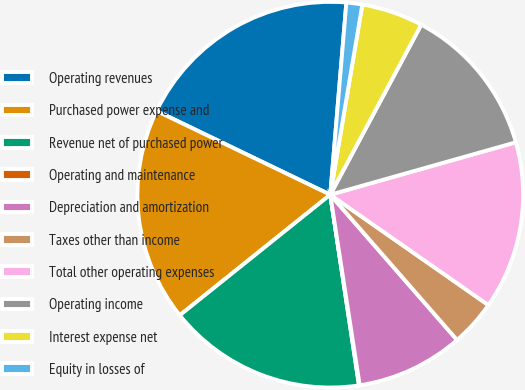Convert chart to OTSL. <chart><loc_0><loc_0><loc_500><loc_500><pie_chart><fcel>Operating revenues<fcel>Purchased power expense and<fcel>Revenue net of purchased power<fcel>Operating and maintenance<fcel>Depreciation and amortization<fcel>Taxes other than income<fcel>Total other operating expenses<fcel>Operating income<fcel>Interest expense net<fcel>Equity in losses of<nl><fcel>19.18%<fcel>17.9%<fcel>16.63%<fcel>0.06%<fcel>8.98%<fcel>3.88%<fcel>14.08%<fcel>12.8%<fcel>5.16%<fcel>1.33%<nl></chart> 